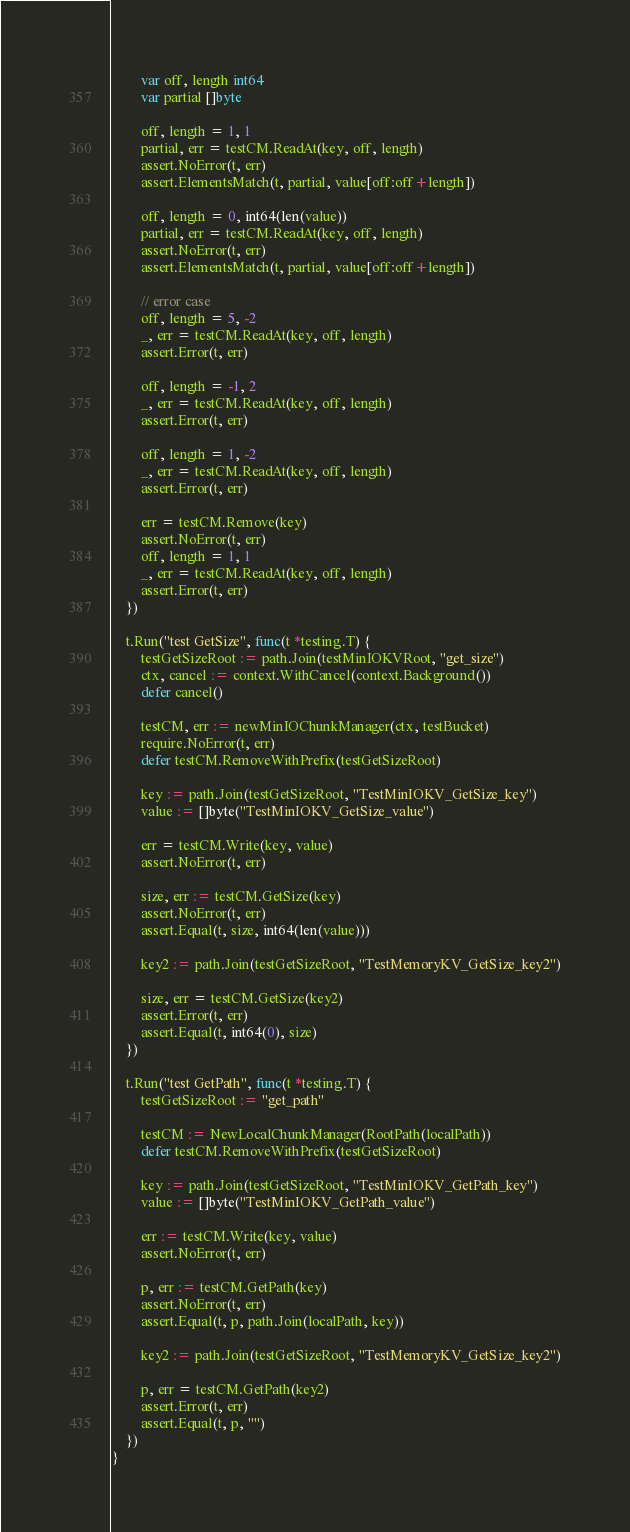<code> <loc_0><loc_0><loc_500><loc_500><_Go_>		var off, length int64
		var partial []byte

		off, length = 1, 1
		partial, err = testCM.ReadAt(key, off, length)
		assert.NoError(t, err)
		assert.ElementsMatch(t, partial, value[off:off+length])

		off, length = 0, int64(len(value))
		partial, err = testCM.ReadAt(key, off, length)
		assert.NoError(t, err)
		assert.ElementsMatch(t, partial, value[off:off+length])

		// error case
		off, length = 5, -2
		_, err = testCM.ReadAt(key, off, length)
		assert.Error(t, err)

		off, length = -1, 2
		_, err = testCM.ReadAt(key, off, length)
		assert.Error(t, err)

		off, length = 1, -2
		_, err = testCM.ReadAt(key, off, length)
		assert.Error(t, err)

		err = testCM.Remove(key)
		assert.NoError(t, err)
		off, length = 1, 1
		_, err = testCM.ReadAt(key, off, length)
		assert.Error(t, err)
	})

	t.Run("test GetSize", func(t *testing.T) {
		testGetSizeRoot := path.Join(testMinIOKVRoot, "get_size")
		ctx, cancel := context.WithCancel(context.Background())
		defer cancel()

		testCM, err := newMinIOChunkManager(ctx, testBucket)
		require.NoError(t, err)
		defer testCM.RemoveWithPrefix(testGetSizeRoot)

		key := path.Join(testGetSizeRoot, "TestMinIOKV_GetSize_key")
		value := []byte("TestMinIOKV_GetSize_value")

		err = testCM.Write(key, value)
		assert.NoError(t, err)

		size, err := testCM.GetSize(key)
		assert.NoError(t, err)
		assert.Equal(t, size, int64(len(value)))

		key2 := path.Join(testGetSizeRoot, "TestMemoryKV_GetSize_key2")

		size, err = testCM.GetSize(key2)
		assert.Error(t, err)
		assert.Equal(t, int64(0), size)
	})

	t.Run("test GetPath", func(t *testing.T) {
		testGetSizeRoot := "get_path"

		testCM := NewLocalChunkManager(RootPath(localPath))
		defer testCM.RemoveWithPrefix(testGetSizeRoot)

		key := path.Join(testGetSizeRoot, "TestMinIOKV_GetPath_key")
		value := []byte("TestMinIOKV_GetPath_value")

		err := testCM.Write(key, value)
		assert.NoError(t, err)

		p, err := testCM.GetPath(key)
		assert.NoError(t, err)
		assert.Equal(t, p, path.Join(localPath, key))

		key2 := path.Join(testGetSizeRoot, "TestMemoryKV_GetSize_key2")

		p, err = testCM.GetPath(key2)
		assert.Error(t, err)
		assert.Equal(t, p, "")
	})
}
</code> 